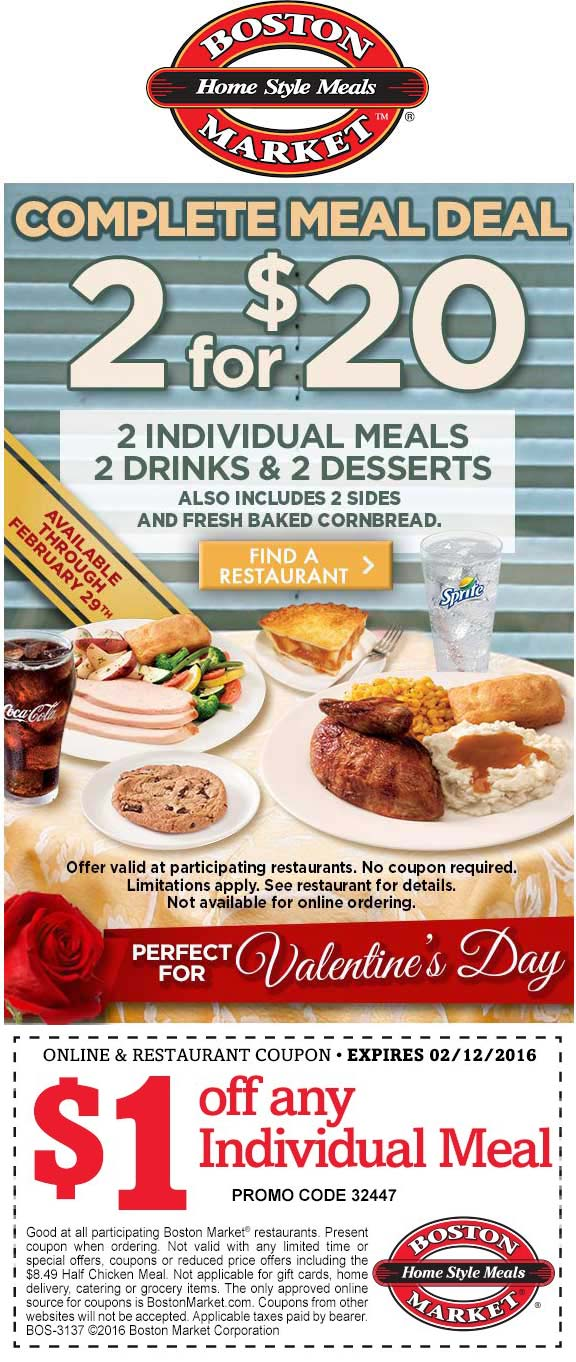Can the promotional code provided in the coupon be used for both onsite and online orders? What are the limitations? The coupon provides a $1 discount on any individual meal and clearly mentions that it can be used at any participating Boston Market restaurant. However, it specifies that the offer is not available for online ordering, which indicates that the promotional code can only be used for dining in or picking up directly from the restaurant locations. Additional limitations include that the deal is not valid with any other promotions or for purchasing gift cards, and it can't be used for delivery orders, catering, or grocery items. 